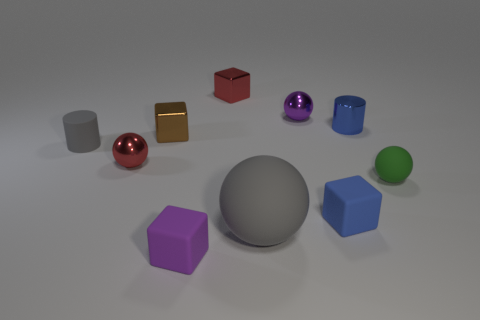What colors are the blocks in the image? The blocks in the image are red, gold, purple, and blue. 